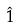Convert formula to latex. <formula><loc_0><loc_0><loc_500><loc_500>\hat { 1 }</formula> 